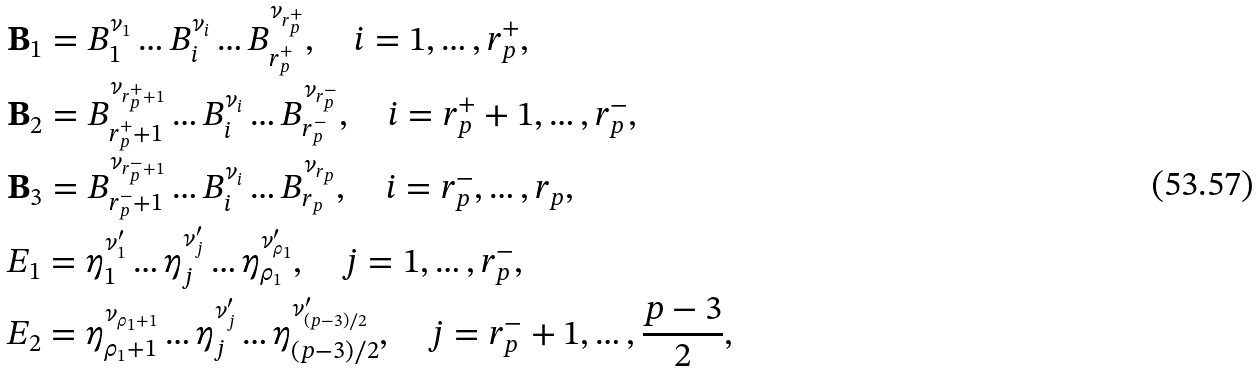<formula> <loc_0><loc_0><loc_500><loc_500>& \mathbf B _ { 1 } = B _ { 1 } ^ { \nu _ { 1 } } \dots B _ { i } ^ { \nu _ { i } } \dots B _ { r _ { p } ^ { + } } ^ { \nu _ { r _ { p } ^ { + } } } , \quad i = 1 , \dots , r _ { p } ^ { + } , \\ & \mathbf B _ { 2 } = B _ { r _ { p } ^ { + } + 1 } ^ { \nu _ { r _ { p } ^ { + } + 1 } } \dots B _ { i } ^ { \nu _ { i } } \dots B _ { r _ { p } ^ { - } } ^ { \nu _ { r _ { p } ^ { - } } } , \quad i = r _ { p } ^ { + } + 1 , \dots , r _ { p } ^ { - } , \\ & \mathbf B _ { 3 } = B _ { r _ { p } ^ { - } + 1 } ^ { \nu _ { r _ { p } ^ { - } + 1 } } \dots B _ { i } ^ { \nu _ { i } } \dots B _ { r _ { p } } ^ { \nu _ { r _ { p } } } , \quad i = r _ { p } ^ { - } , \dots , r _ { p } , \\ & { E } _ { 1 } = \eta _ { 1 } ^ { \nu _ { 1 } ^ { \prime } } \dots \eta _ { j } ^ { \nu _ { j } ^ { \prime } } \dots \eta _ { \rho _ { 1 } } ^ { \nu _ { \rho _ { 1 } } ^ { \prime } } , \quad j = 1 , \dots , r _ { p } ^ { - } , \\ & { E } _ { 2 } = \eta _ { \rho _ { 1 } + 1 } ^ { \nu _ { \rho _ { 1 } + 1 } } \dots \eta _ { j } ^ { \nu _ { j } ^ { \prime } } \dots \eta _ { ( p - 3 ) / 2 } ^ { \nu _ { ( p - 3 ) / 2 } ^ { \prime } } , \quad j = r _ { p } ^ { - } + 1 , \dots , \frac { p - 3 } { 2 } , \\</formula> 